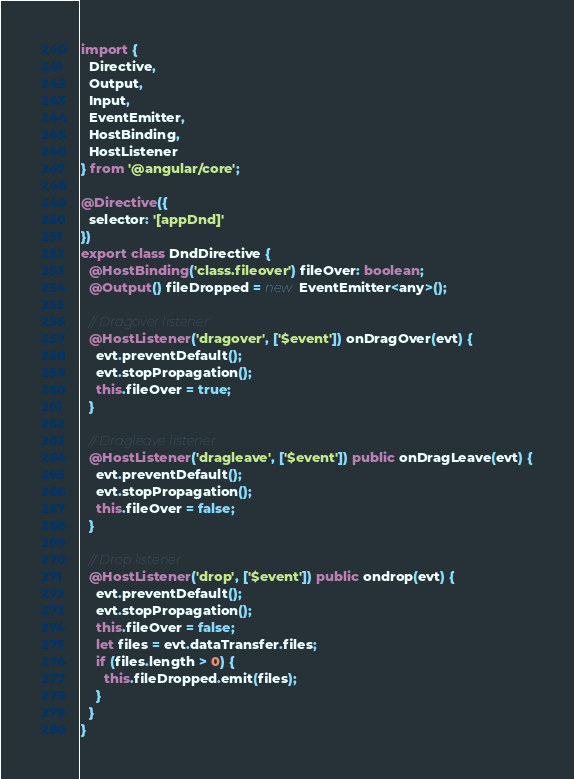Convert code to text. <code><loc_0><loc_0><loc_500><loc_500><_TypeScript_>
import {
  Directive,
  Output,
  Input,
  EventEmitter,
  HostBinding,
  HostListener
} from '@angular/core';

@Directive({
  selector: '[appDnd]'
})
export class DndDirective {
  @HostBinding('class.fileover') fileOver: boolean;
  @Output() fileDropped = new EventEmitter<any>();

  // Dragover listener
  @HostListener('dragover', ['$event']) onDragOver(evt) {
    evt.preventDefault();
    evt.stopPropagation();
    this.fileOver = true;
  }

  // Dragleave listener
  @HostListener('dragleave', ['$event']) public onDragLeave(evt) {
    evt.preventDefault();
    evt.stopPropagation();
    this.fileOver = false;
  }

  // Drop listener
  @HostListener('drop', ['$event']) public ondrop(evt) {
    evt.preventDefault();
    evt.stopPropagation();
    this.fileOver = false;
    let files = evt.dataTransfer.files;
    if (files.length > 0) {
      this.fileDropped.emit(files);
    }
  }
}</code> 